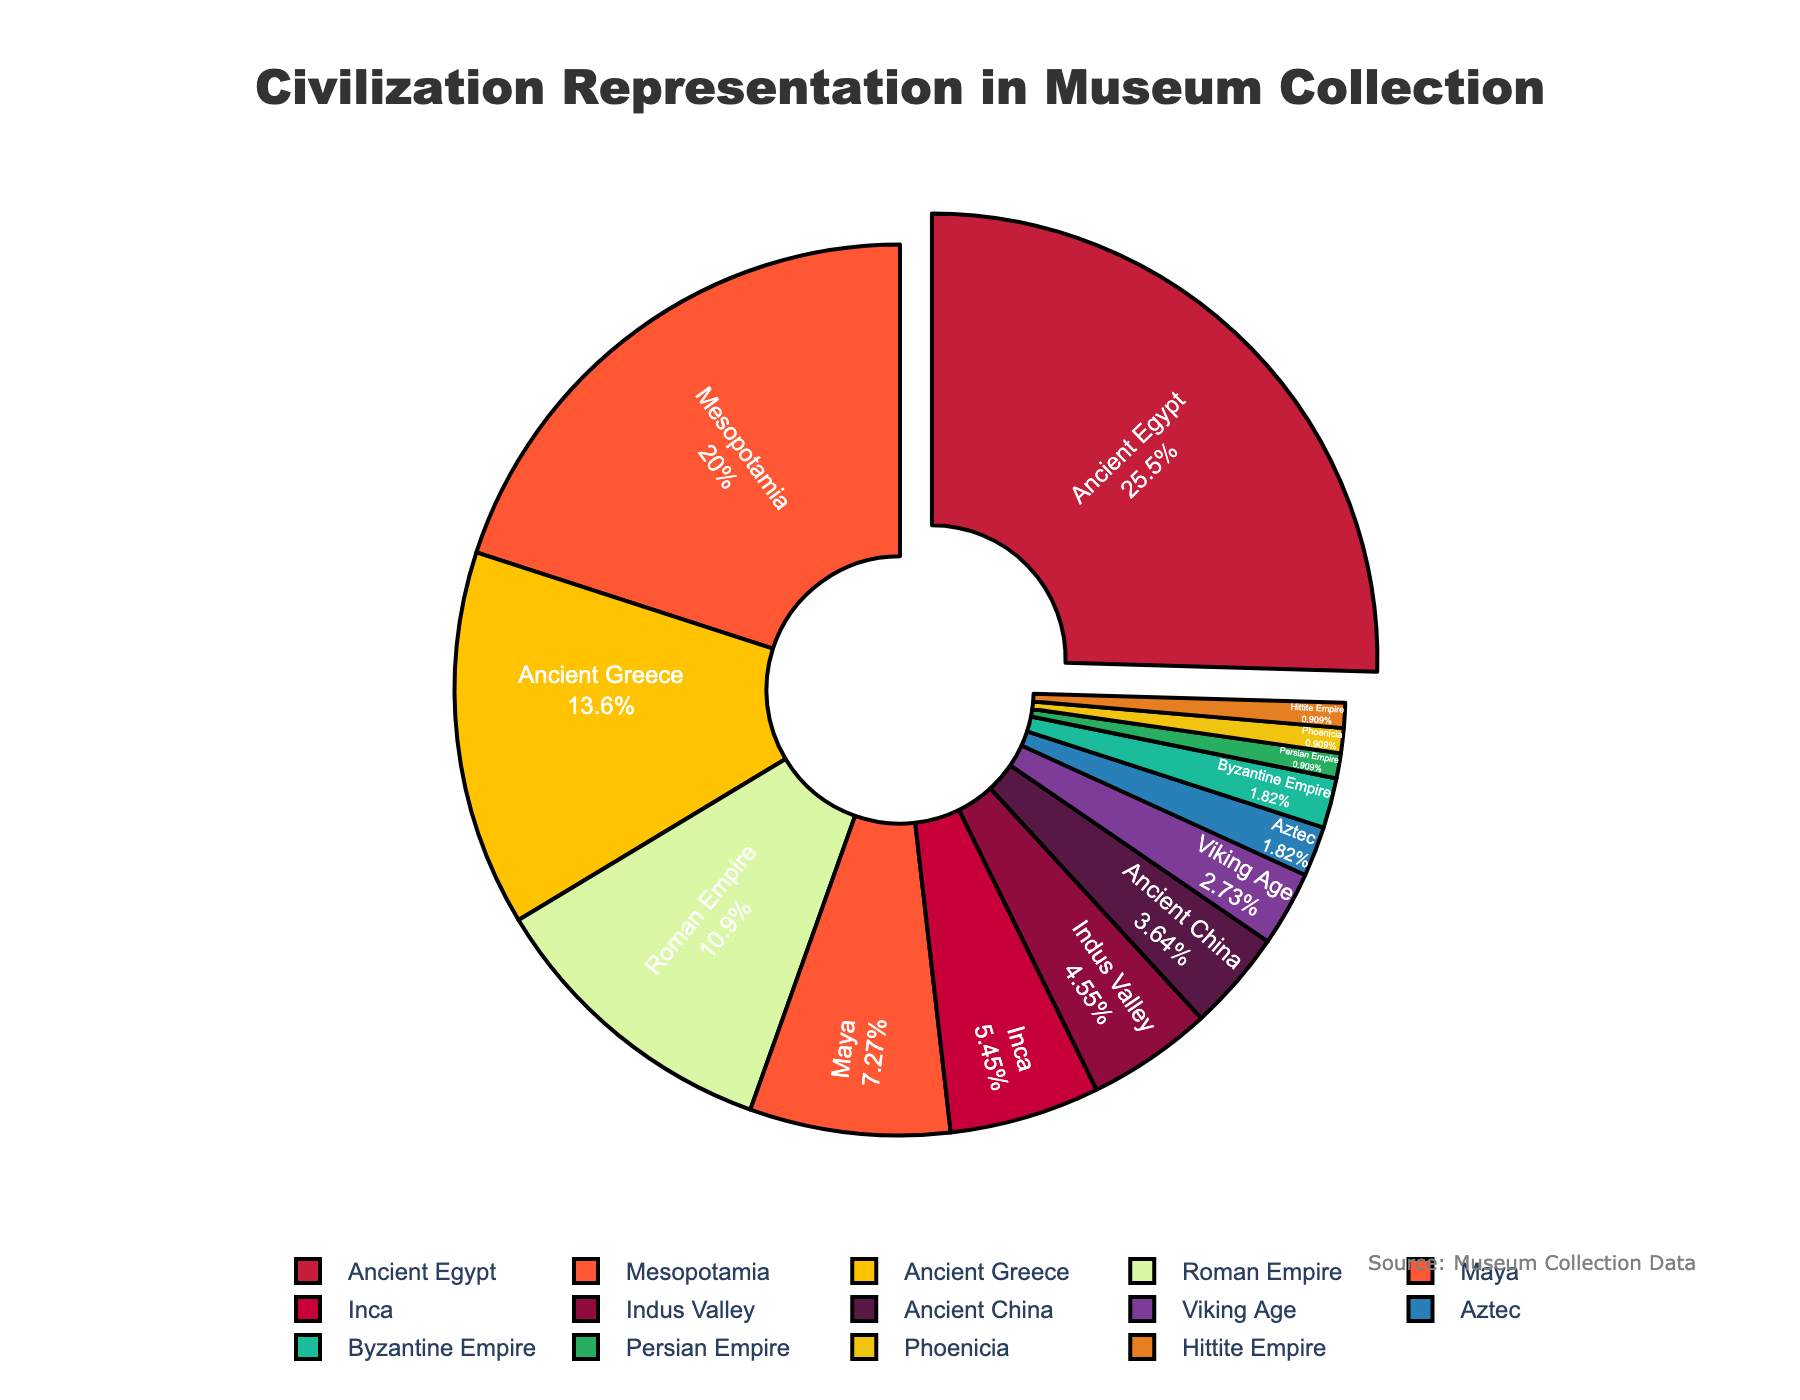What civilization is most represented in the museum's collection? The pie chart shows the civilization with the largest percentage, which visually stands out by having the largest sector and a distinct pull-out effect. Ancient Egypt, at 28%, is the largest.
Answer: Ancient Egypt What is the percentage difference between Ancient Egypt and Mesopotamia? From the pie chart, Ancient Egypt is at 28% and Mesopotamia is at 22%. The difference is 28% - 22% = 6%.
Answer: 6% How many civilizations have a representation percentage of 5% or less? By observing the segments labeled with their respective percentages, we identify Indus Valley (5%), Ancient China (4%), Viking Age (3%), Aztec (2%), Byzantine Empire (2%), Persian Empire (1%), Phoenicia (1%), and Hittite Empire (1%). In total, there are 8 civilizations.
Answer: 8 Which two civilizations combined have a similar percentage to Ancient Egypt? By summing the percentages of Mesopotamia (22%) and Roman Empire (12%), we get 22% + 12% = 34%, closely matching Ancient Egypt's 28%.
Answer: Mesopotamia and Roman Empire What color represents the Inca civilization in the pie chart? The Inca civilization has a pie chart segment with 6%, corresponding to a distinct color. The segment's color must be noted directly from the chart. The color representing Inca is dark purple.
Answer: Dark purple Which civilizations are represented equally in the museum's collection? The chart shows two civilizations both at 2%, indicated similarly in size: Byzantine Empire and Aztec.
Answer: Byzantine Empire and Aztec What is the combined representation percentage of Ancient Greece and the Roman Empire? The chart lists 15% for Ancient Greece and 12% for Roman Empire. The combined percentage is 15% + 12% = 27%.
Answer: 27% What is the least represented civilization? The smallest segment corresponds to a civilization with the lowest percentage, 1%. Several slices share this percentage: Persian Empire, Phoenicia, and Hittite Empire.
Answer: Persian Empire, Phoenicia, Hittite Empire By how much does the representation of the Maya civilization exceed that of Ancient China? Maya has 8% represented by a larger segment compared to Ancient China's 4%. The excess amount is 8% - 4% = 4%.
Answer: 4% Which civilizations occupy at least 20% of the collection together? Adding the percentages of major civilizations: Ancient Egypt (28%) and Mesopotamia (22%). Together, they occupy at least 20% of the collection.
Answer: Ancient Egypt and Mesopotamia 